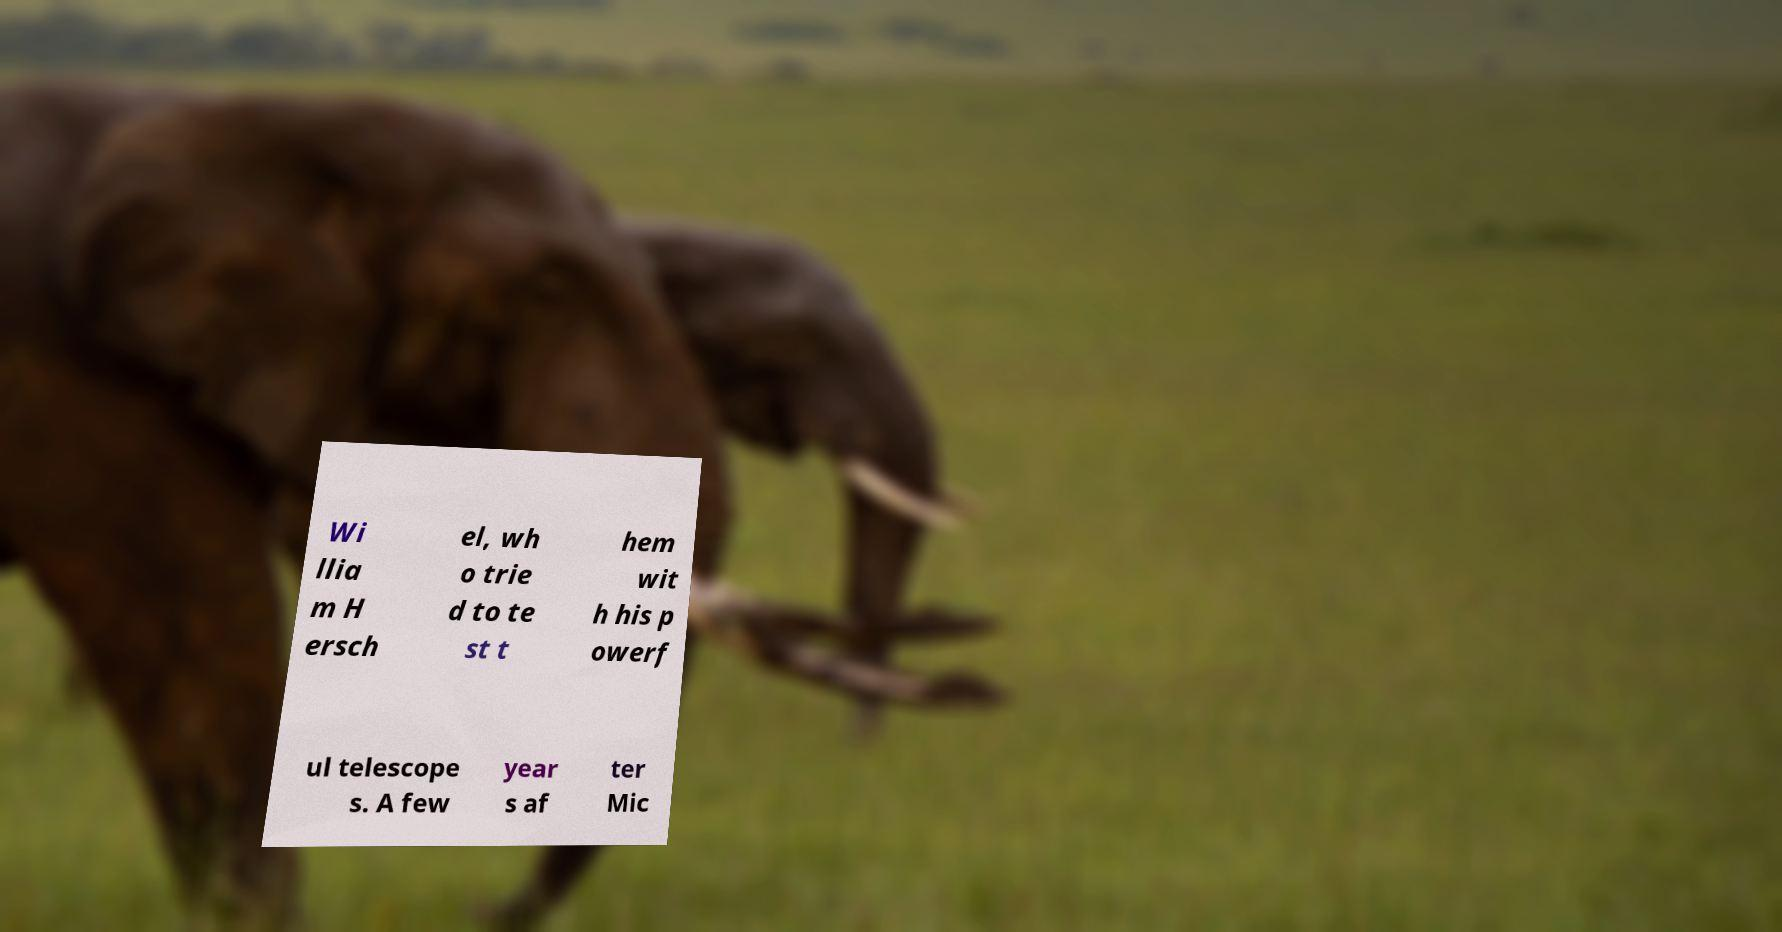Can you read and provide the text displayed in the image?This photo seems to have some interesting text. Can you extract and type it out for me? Wi llia m H ersch el, wh o trie d to te st t hem wit h his p owerf ul telescope s. A few year s af ter Mic 